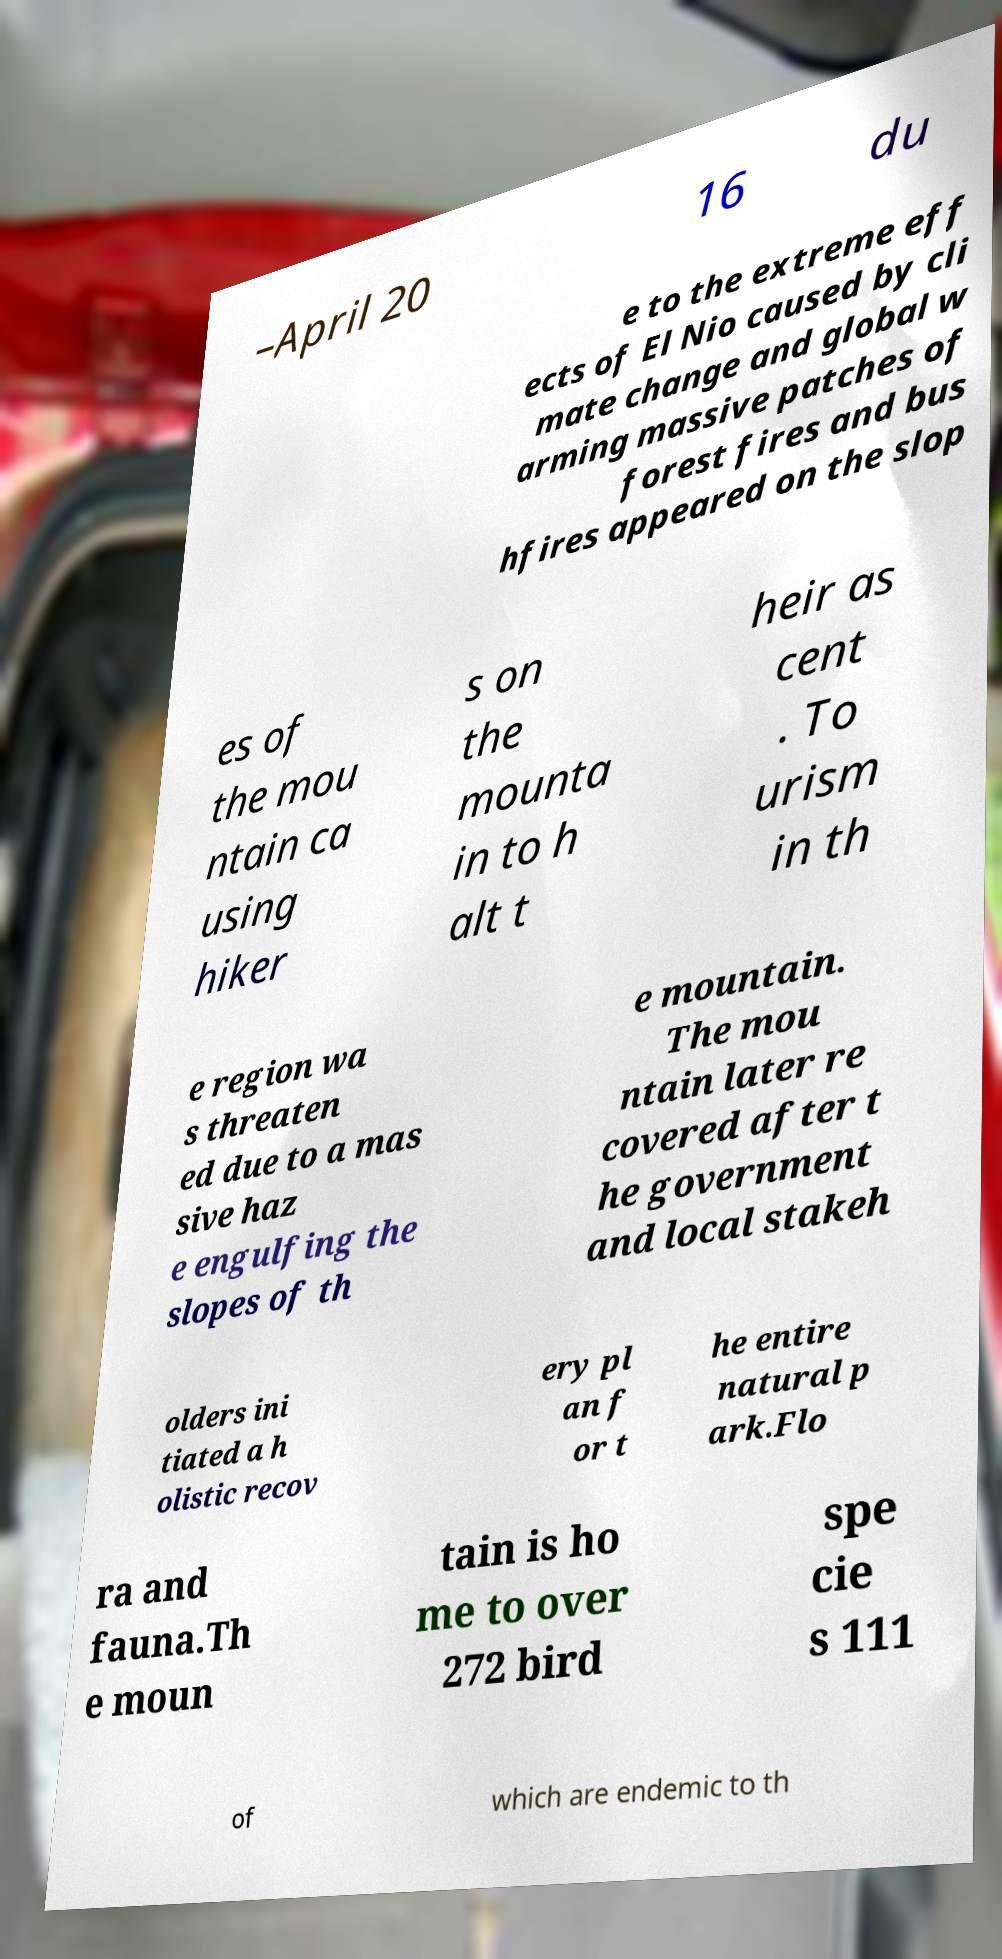Could you assist in decoding the text presented in this image and type it out clearly? –April 20 16 du e to the extreme eff ects of El Nio caused by cli mate change and global w arming massive patches of forest fires and bus hfires appeared on the slop es of the mou ntain ca using hiker s on the mounta in to h alt t heir as cent . To urism in th e region wa s threaten ed due to a mas sive haz e engulfing the slopes of th e mountain. The mou ntain later re covered after t he government and local stakeh olders ini tiated a h olistic recov ery pl an f or t he entire natural p ark.Flo ra and fauna.Th e moun tain is ho me to over 272 bird spe cie s 111 of which are endemic to th 